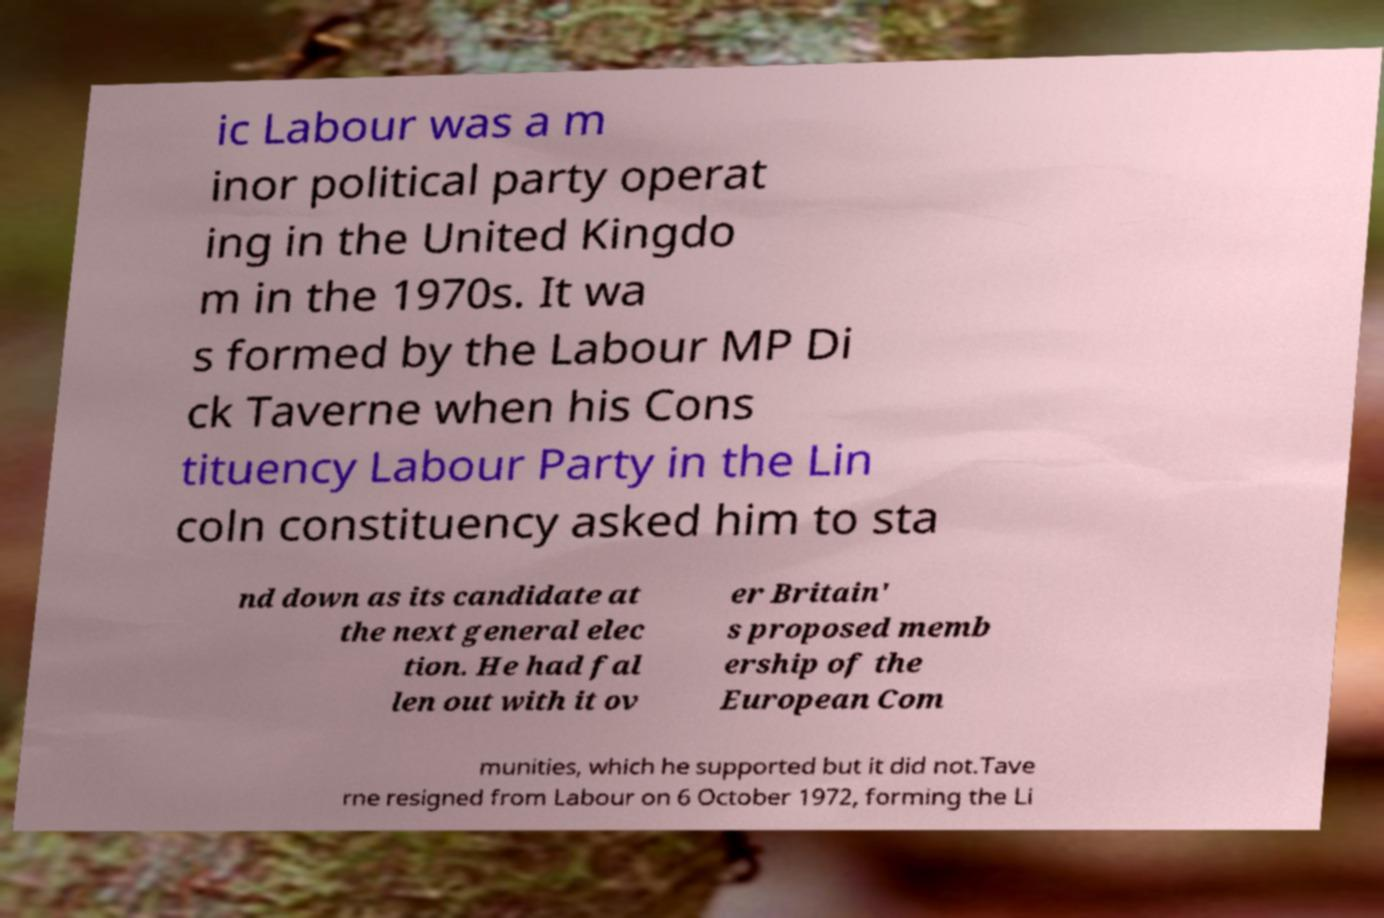Can you accurately transcribe the text from the provided image for me? ic Labour was a m inor political party operat ing in the United Kingdo m in the 1970s. It wa s formed by the Labour MP Di ck Taverne when his Cons tituency Labour Party in the Lin coln constituency asked him to sta nd down as its candidate at the next general elec tion. He had fal len out with it ov er Britain' s proposed memb ership of the European Com munities, which he supported but it did not.Tave rne resigned from Labour on 6 October 1972, forming the Li 